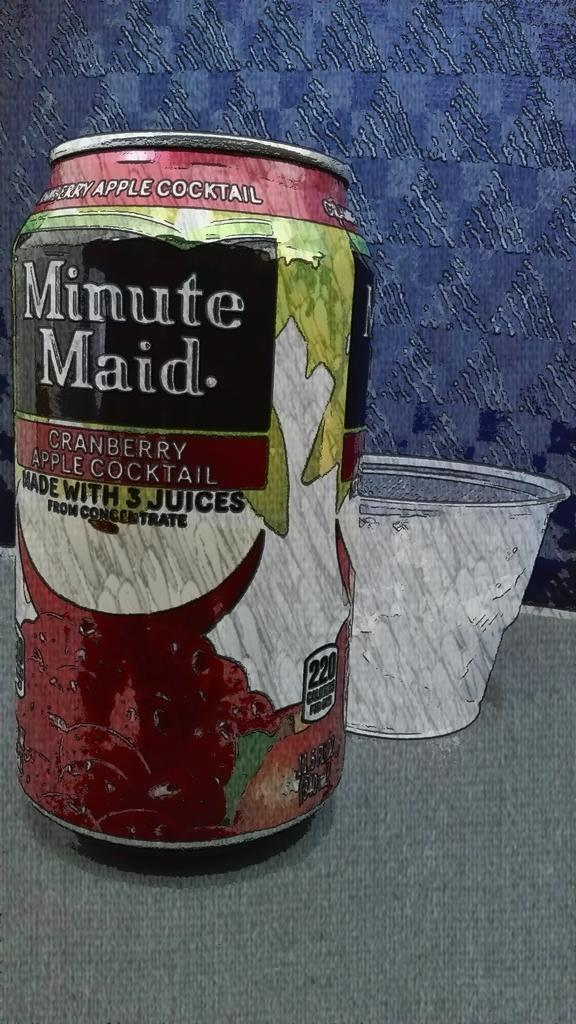<image>
Relay a brief, clear account of the picture shown. a Minute Maid cranberry apple cocktail in a can. 